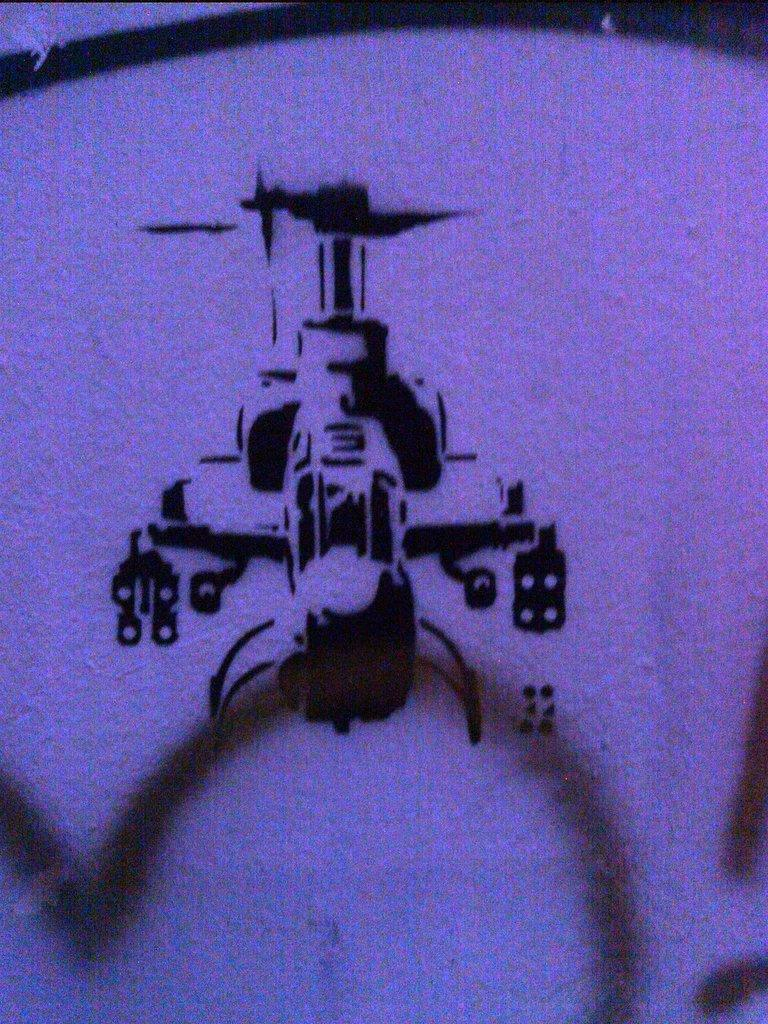What is present on the wall in the image? There is a sketch of a helicopter on the wall. Can you describe the wall in the image? The wall is a plain surface with the helicopter sketch on it. How many cows are present in the image? There are no cows present in the image; it features a wall with a helicopter sketch. What word might be used to describe the action of stopping the helicopter in the image? There is no action of stopping the helicopter in the image, as it is a static sketch on the wall. 